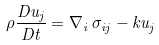<formula> <loc_0><loc_0><loc_500><loc_500>\rho \frac { D u _ { j } } { D t } = \nabla _ { i } \, \sigma _ { i j } - k u _ { j }</formula> 